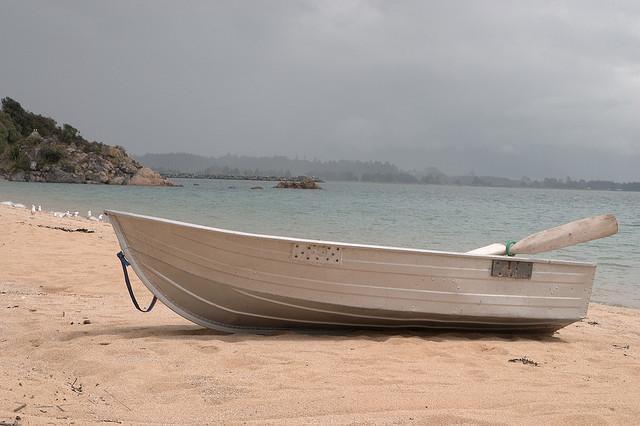What propels this boat?
Choose the correct response, then elucidate: 'Answer: answer
Rationale: rationale.'
Options: Electricity, sail, oar, gas engine. Answer: oar.
Rationale: It's sticking out the side and the other options aren't on the boat. 